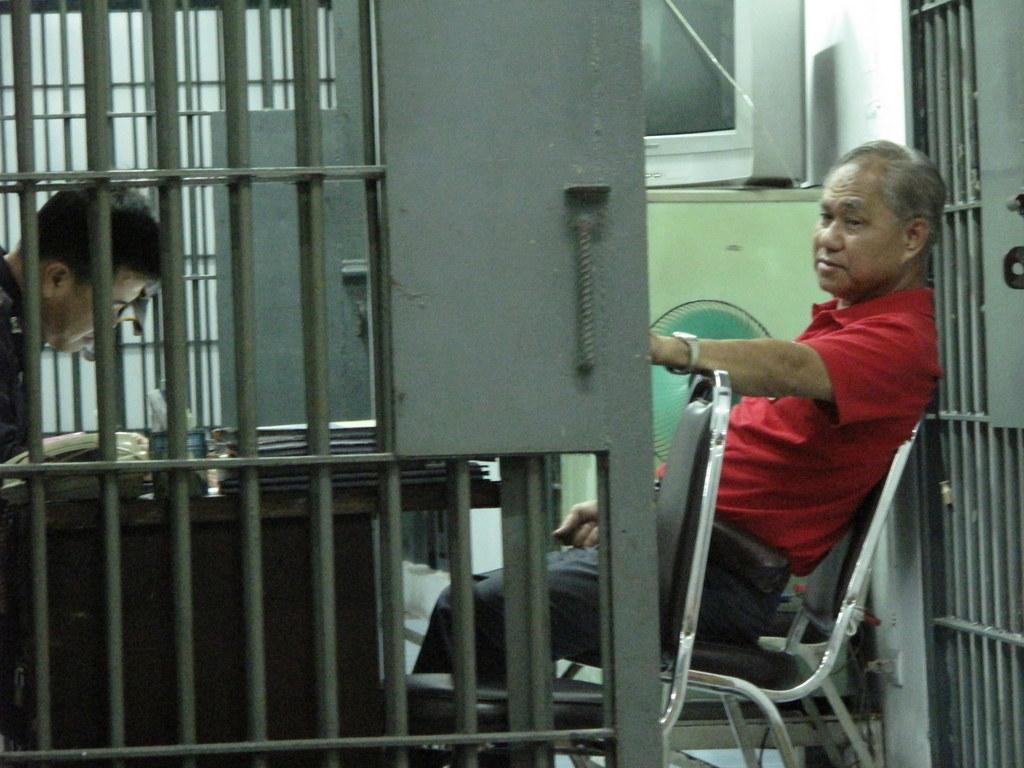In one or two sentences, can you explain what this image depicts? In this image there are two persons sitting on the chair. On the table there are books. 